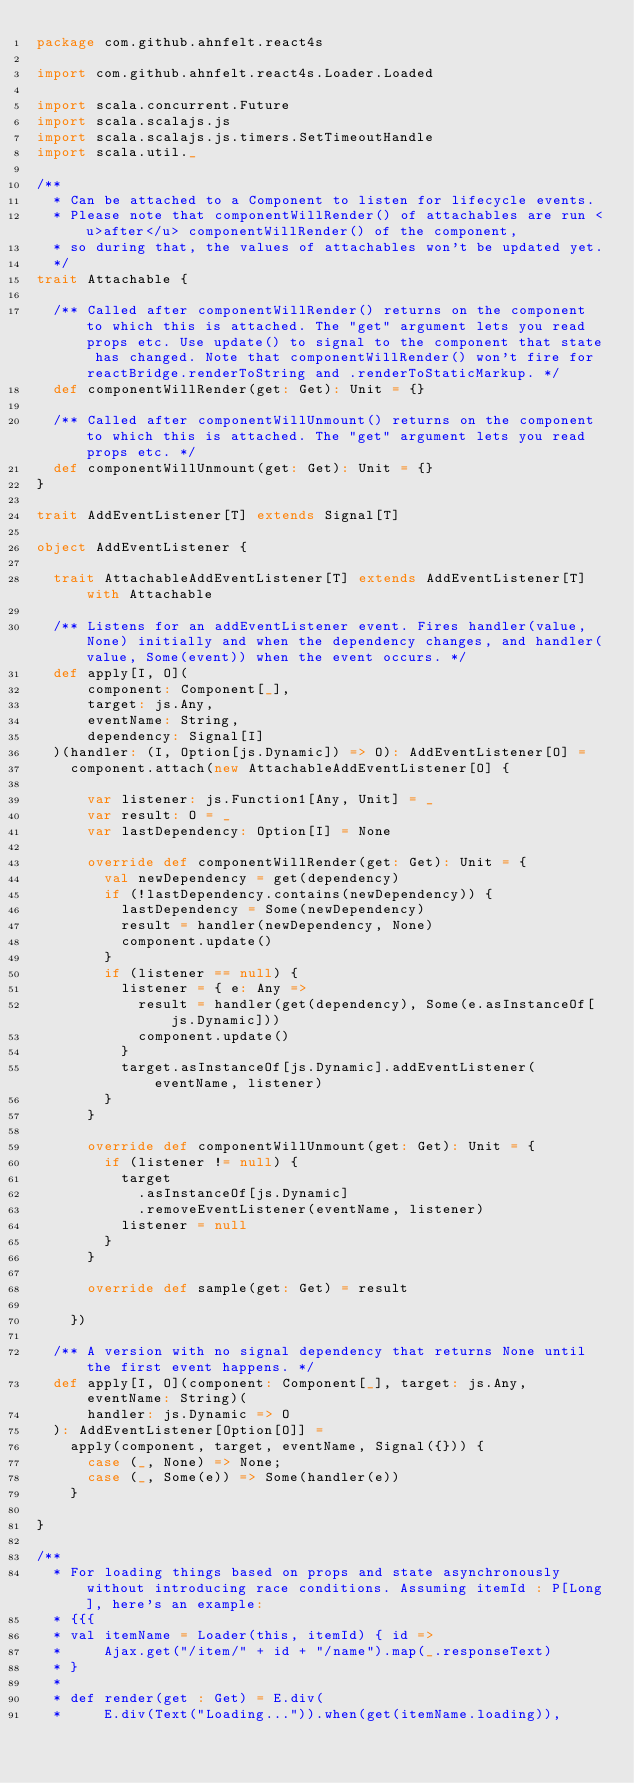Convert code to text. <code><loc_0><loc_0><loc_500><loc_500><_Scala_>package com.github.ahnfelt.react4s

import com.github.ahnfelt.react4s.Loader.Loaded

import scala.concurrent.Future
import scala.scalajs.js
import scala.scalajs.js.timers.SetTimeoutHandle
import scala.util._

/**
  * Can be attached to a Component to listen for lifecycle events.
  * Please note that componentWillRender() of attachables are run <u>after</u> componentWillRender() of the component,
  * so during that, the values of attachables won't be updated yet.
  */
trait Attachable {

  /** Called after componentWillRender() returns on the component to which this is attached. The "get" argument lets you read props etc. Use update() to signal to the component that state has changed. Note that componentWillRender() won't fire for reactBridge.renderToString and .renderToStaticMarkup. */
  def componentWillRender(get: Get): Unit = {}

  /** Called after componentWillUnmount() returns on the component to which this is attached. The "get" argument lets you read props etc. */
  def componentWillUnmount(get: Get): Unit = {}
}

trait AddEventListener[T] extends Signal[T]

object AddEventListener {

  trait AttachableAddEventListener[T] extends AddEventListener[T] with Attachable

  /** Listens for an addEventListener event. Fires handler(value, None) initially and when the dependency changes, and handler(value, Some(event)) when the event occurs. */
  def apply[I, O](
      component: Component[_],
      target: js.Any,
      eventName: String,
      dependency: Signal[I]
  )(handler: (I, Option[js.Dynamic]) => O): AddEventListener[O] =
    component.attach(new AttachableAddEventListener[O] {

      var listener: js.Function1[Any, Unit] = _
      var result: O = _
      var lastDependency: Option[I] = None

      override def componentWillRender(get: Get): Unit = {
        val newDependency = get(dependency)
        if (!lastDependency.contains(newDependency)) {
          lastDependency = Some(newDependency)
          result = handler(newDependency, None)
          component.update()
        }
        if (listener == null) {
          listener = { e: Any =>
            result = handler(get(dependency), Some(e.asInstanceOf[js.Dynamic]))
            component.update()
          }
          target.asInstanceOf[js.Dynamic].addEventListener(eventName, listener)
        }
      }

      override def componentWillUnmount(get: Get): Unit = {
        if (listener != null) {
          target
            .asInstanceOf[js.Dynamic]
            .removeEventListener(eventName, listener)
          listener = null
        }
      }

      override def sample(get: Get) = result

    })

  /** A version with no signal dependency that returns None until the first event happens. */
  def apply[I, O](component: Component[_], target: js.Any, eventName: String)(
      handler: js.Dynamic => O
  ): AddEventListener[Option[O]] =
    apply(component, target, eventName, Signal({})) {
      case (_, None) => None;
      case (_, Some(e)) => Some(handler(e))
    }

}

/**
  * For loading things based on props and state asynchronously without introducing race conditions. Assuming itemId : P[Long], here's an example:
  * {{{
  * val itemName = Loader(this, itemId) { id =>
  *     Ajax.get("/item/" + id + "/name").map(_.responseText)
  * }
  *
  * def render(get : Get) = E.div(
  *     E.div(Text("Loading...")).when(get(itemName.loading)),</code> 